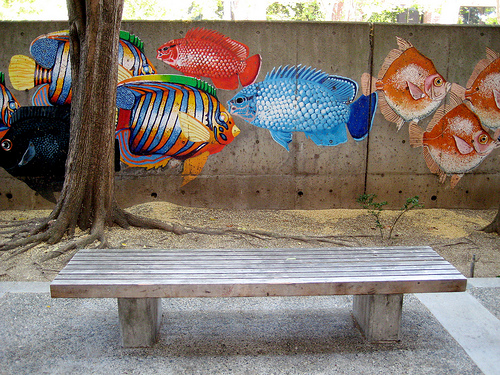<image>
Is the fish on the wall? Yes. Looking at the image, I can see the fish is positioned on top of the wall, with the wall providing support. 